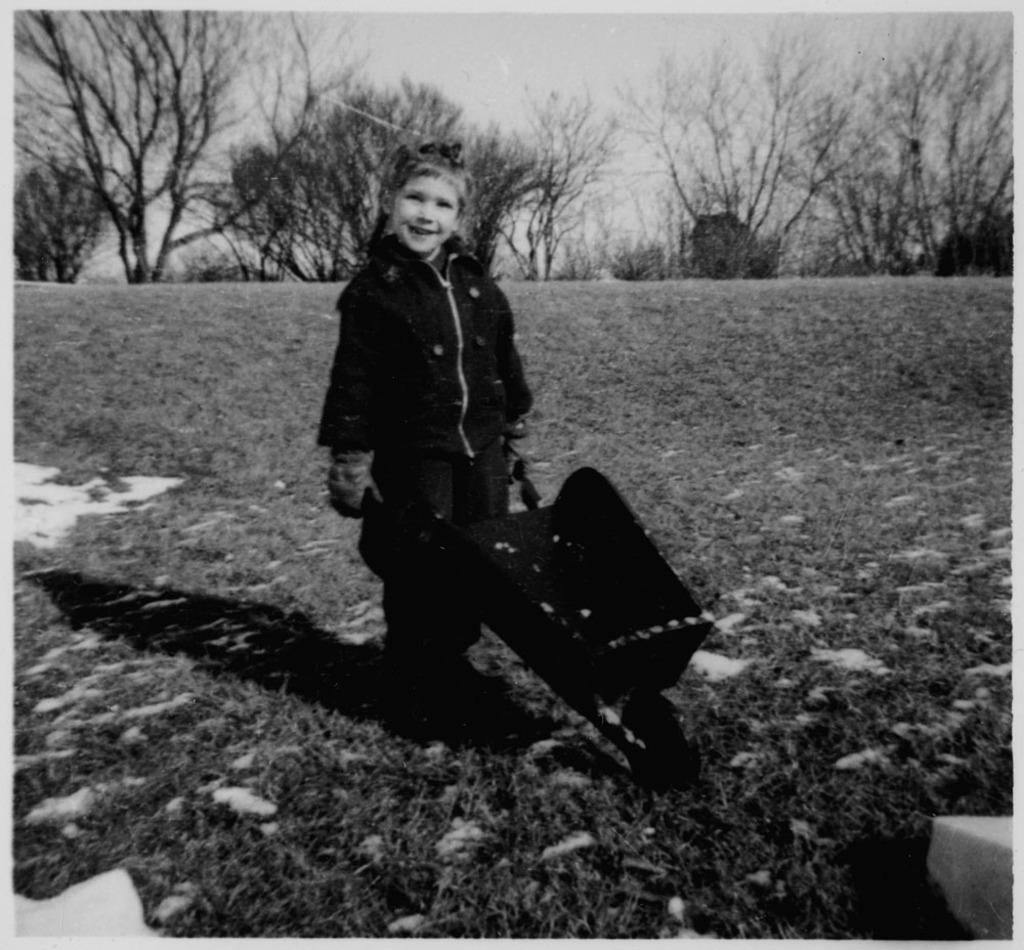What is the color scheme of the image? The image is black and white. What can be seen in the background of the image? There are trees in the background of the image. What is the child in the image doing? The child is standing and smiling in the image. What is the black object on the ground in the image? The black object on the ground in the image is not specified, but it is mentioned as being present. What grade did the child receive for their performance in the image? There is no indication of a performance or grade in the image, as it features a child standing and smiling with trees in the background. 